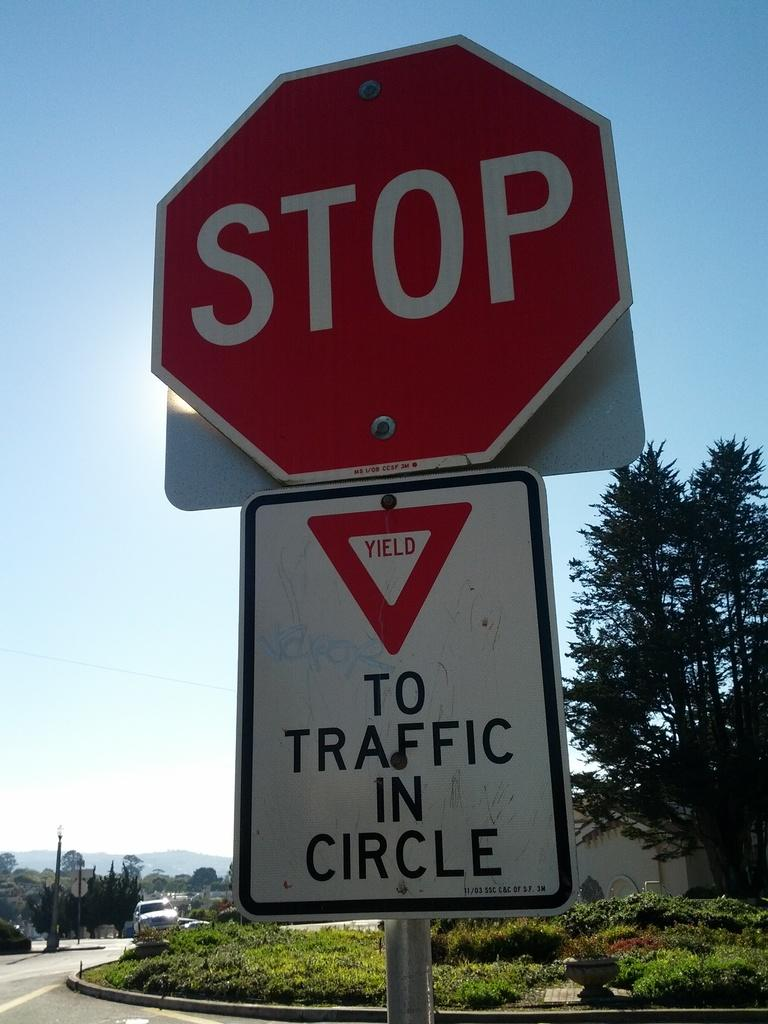Provide a one-sentence caption for the provided image. A red stop sign that says STOP on it. 